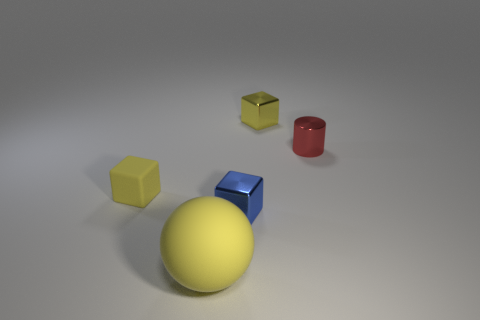Could you tell me the lighting direction in the image? The lighting in the image appears to be coming from the upper left side, as evidenced by the shadows being cast to the lower right of the objects. This creates a soft gradient on the surface, giving depth and dimension to the scene. 